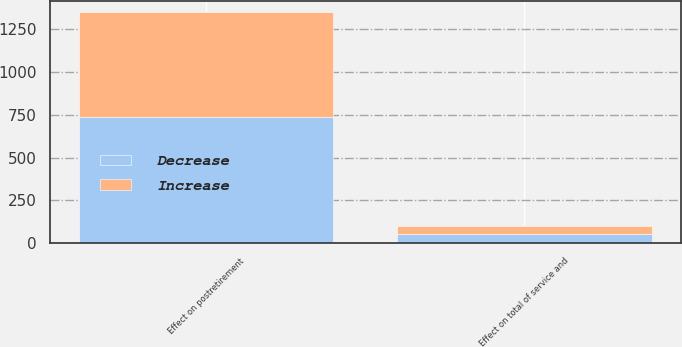<chart> <loc_0><loc_0><loc_500><loc_500><stacked_bar_chart><ecel><fcel>Effect on total of service and<fcel>Effect on postretirement<nl><fcel>Decrease<fcel>54<fcel>736<nl><fcel>Increase<fcel>45<fcel>613<nl></chart> 